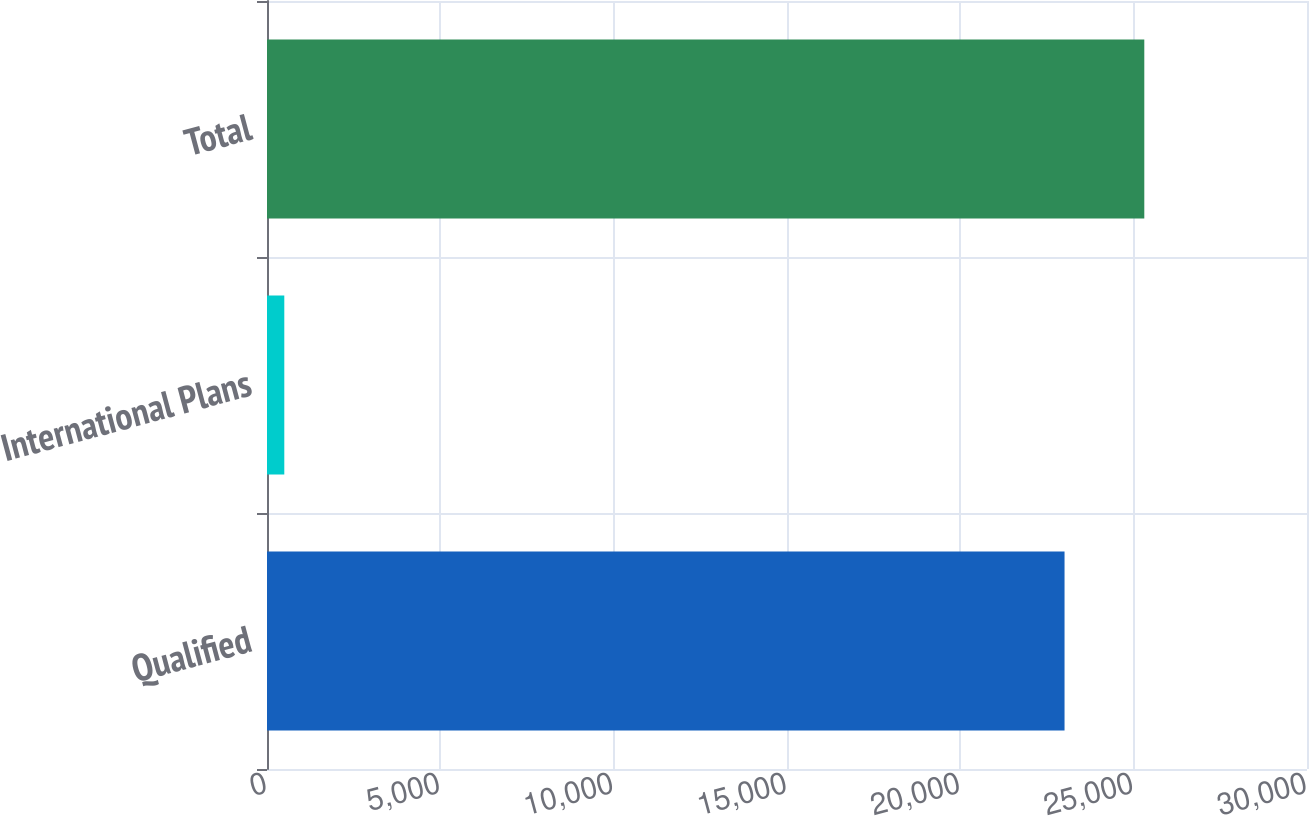<chart> <loc_0><loc_0><loc_500><loc_500><bar_chart><fcel>Qualified<fcel>International Plans<fcel>Total<nl><fcel>23006<fcel>499<fcel>25306.6<nl></chart> 